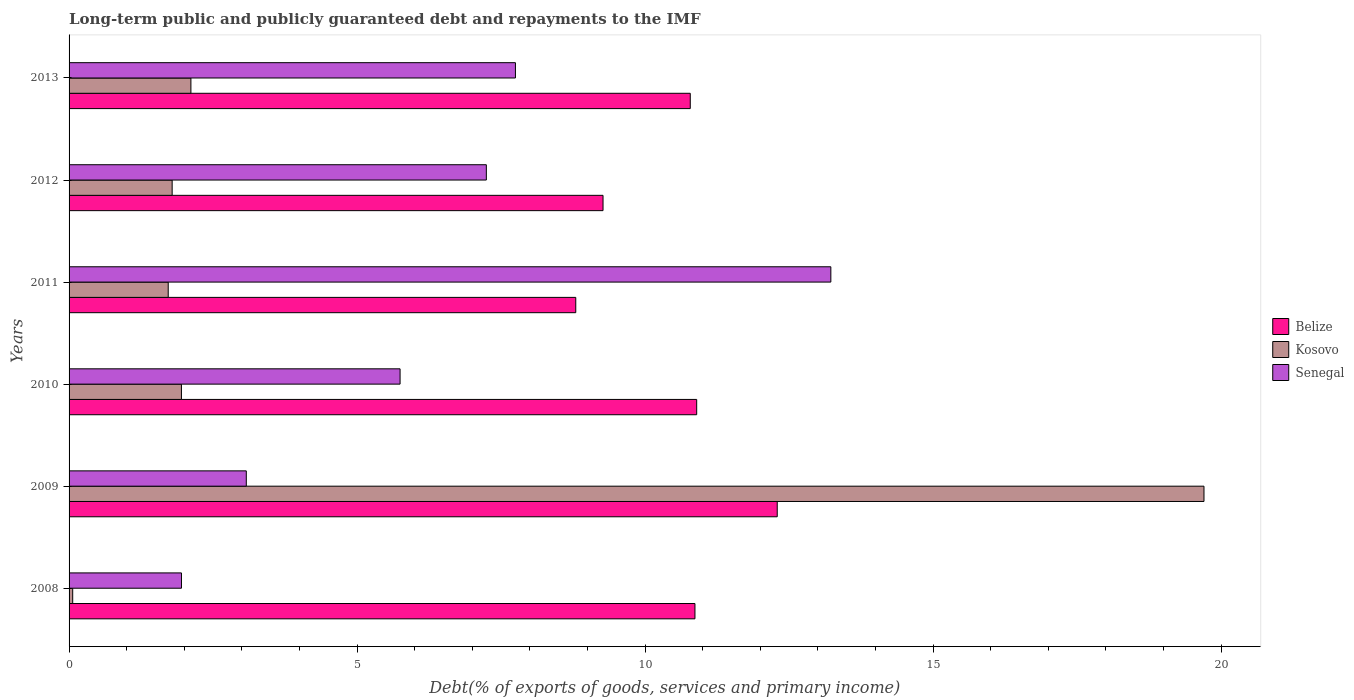How many different coloured bars are there?
Offer a terse response. 3. Are the number of bars per tick equal to the number of legend labels?
Give a very brief answer. Yes. How many bars are there on the 4th tick from the bottom?
Provide a short and direct response. 3. What is the debt and repayments in Kosovo in 2013?
Keep it short and to the point. 2.12. Across all years, what is the maximum debt and repayments in Kosovo?
Keep it short and to the point. 19.7. Across all years, what is the minimum debt and repayments in Belize?
Keep it short and to the point. 8.8. In which year was the debt and repayments in Belize maximum?
Ensure brevity in your answer.  2009. In which year was the debt and repayments in Belize minimum?
Your response must be concise. 2011. What is the total debt and repayments in Belize in the graph?
Offer a terse response. 62.91. What is the difference between the debt and repayments in Senegal in 2009 and that in 2011?
Provide a short and direct response. -10.15. What is the difference between the debt and repayments in Kosovo in 2010 and the debt and repayments in Senegal in 2009?
Your response must be concise. -1.13. What is the average debt and repayments in Belize per year?
Provide a short and direct response. 10.48. In the year 2009, what is the difference between the debt and repayments in Belize and debt and repayments in Kosovo?
Offer a terse response. -7.41. What is the ratio of the debt and repayments in Belize in 2008 to that in 2012?
Give a very brief answer. 1.17. Is the debt and repayments in Kosovo in 2011 less than that in 2013?
Provide a short and direct response. Yes. Is the difference between the debt and repayments in Belize in 2008 and 2012 greater than the difference between the debt and repayments in Kosovo in 2008 and 2012?
Offer a terse response. Yes. What is the difference between the highest and the second highest debt and repayments in Senegal?
Give a very brief answer. 5.48. What is the difference between the highest and the lowest debt and repayments in Belize?
Give a very brief answer. 3.5. What does the 2nd bar from the top in 2008 represents?
Your answer should be compact. Kosovo. What does the 3rd bar from the bottom in 2009 represents?
Provide a short and direct response. Senegal. Is it the case that in every year, the sum of the debt and repayments in Senegal and debt and repayments in Belize is greater than the debt and repayments in Kosovo?
Your answer should be compact. No. How many bars are there?
Make the answer very short. 18. Are all the bars in the graph horizontal?
Your answer should be very brief. Yes. How many years are there in the graph?
Offer a terse response. 6. Does the graph contain any zero values?
Ensure brevity in your answer.  No. Does the graph contain grids?
Keep it short and to the point. No. Where does the legend appear in the graph?
Your response must be concise. Center right. How many legend labels are there?
Your answer should be very brief. 3. How are the legend labels stacked?
Provide a short and direct response. Vertical. What is the title of the graph?
Give a very brief answer. Long-term public and publicly guaranteed debt and repayments to the IMF. Does "Madagascar" appear as one of the legend labels in the graph?
Give a very brief answer. No. What is the label or title of the X-axis?
Offer a very short reply. Debt(% of exports of goods, services and primary income). What is the label or title of the Y-axis?
Your answer should be compact. Years. What is the Debt(% of exports of goods, services and primary income) in Belize in 2008?
Offer a terse response. 10.87. What is the Debt(% of exports of goods, services and primary income) in Kosovo in 2008?
Offer a very short reply. 0.06. What is the Debt(% of exports of goods, services and primary income) in Senegal in 2008?
Your response must be concise. 1.95. What is the Debt(% of exports of goods, services and primary income) of Belize in 2009?
Offer a terse response. 12.29. What is the Debt(% of exports of goods, services and primary income) in Kosovo in 2009?
Offer a very short reply. 19.7. What is the Debt(% of exports of goods, services and primary income) of Senegal in 2009?
Provide a succinct answer. 3.08. What is the Debt(% of exports of goods, services and primary income) in Belize in 2010?
Keep it short and to the point. 10.9. What is the Debt(% of exports of goods, services and primary income) in Kosovo in 2010?
Provide a succinct answer. 1.95. What is the Debt(% of exports of goods, services and primary income) of Senegal in 2010?
Ensure brevity in your answer.  5.75. What is the Debt(% of exports of goods, services and primary income) in Belize in 2011?
Keep it short and to the point. 8.8. What is the Debt(% of exports of goods, services and primary income) in Kosovo in 2011?
Your answer should be very brief. 1.72. What is the Debt(% of exports of goods, services and primary income) of Senegal in 2011?
Ensure brevity in your answer.  13.22. What is the Debt(% of exports of goods, services and primary income) in Belize in 2012?
Offer a very short reply. 9.27. What is the Debt(% of exports of goods, services and primary income) in Kosovo in 2012?
Provide a short and direct response. 1.79. What is the Debt(% of exports of goods, services and primary income) in Senegal in 2012?
Ensure brevity in your answer.  7.24. What is the Debt(% of exports of goods, services and primary income) of Belize in 2013?
Offer a very short reply. 10.78. What is the Debt(% of exports of goods, services and primary income) of Kosovo in 2013?
Keep it short and to the point. 2.12. What is the Debt(% of exports of goods, services and primary income) of Senegal in 2013?
Offer a very short reply. 7.75. Across all years, what is the maximum Debt(% of exports of goods, services and primary income) of Belize?
Provide a short and direct response. 12.29. Across all years, what is the maximum Debt(% of exports of goods, services and primary income) in Kosovo?
Offer a very short reply. 19.7. Across all years, what is the maximum Debt(% of exports of goods, services and primary income) of Senegal?
Offer a terse response. 13.22. Across all years, what is the minimum Debt(% of exports of goods, services and primary income) in Belize?
Ensure brevity in your answer.  8.8. Across all years, what is the minimum Debt(% of exports of goods, services and primary income) of Kosovo?
Offer a very short reply. 0.06. Across all years, what is the minimum Debt(% of exports of goods, services and primary income) of Senegal?
Your answer should be very brief. 1.95. What is the total Debt(% of exports of goods, services and primary income) in Belize in the graph?
Offer a terse response. 62.91. What is the total Debt(% of exports of goods, services and primary income) in Kosovo in the graph?
Offer a very short reply. 27.34. What is the total Debt(% of exports of goods, services and primary income) of Senegal in the graph?
Keep it short and to the point. 38.99. What is the difference between the Debt(% of exports of goods, services and primary income) in Belize in 2008 and that in 2009?
Ensure brevity in your answer.  -1.43. What is the difference between the Debt(% of exports of goods, services and primary income) in Kosovo in 2008 and that in 2009?
Your response must be concise. -19.64. What is the difference between the Debt(% of exports of goods, services and primary income) in Senegal in 2008 and that in 2009?
Give a very brief answer. -1.13. What is the difference between the Debt(% of exports of goods, services and primary income) of Belize in 2008 and that in 2010?
Make the answer very short. -0.03. What is the difference between the Debt(% of exports of goods, services and primary income) in Kosovo in 2008 and that in 2010?
Offer a terse response. -1.89. What is the difference between the Debt(% of exports of goods, services and primary income) of Senegal in 2008 and that in 2010?
Offer a very short reply. -3.8. What is the difference between the Debt(% of exports of goods, services and primary income) of Belize in 2008 and that in 2011?
Your answer should be compact. 2.07. What is the difference between the Debt(% of exports of goods, services and primary income) in Kosovo in 2008 and that in 2011?
Offer a very short reply. -1.66. What is the difference between the Debt(% of exports of goods, services and primary income) in Senegal in 2008 and that in 2011?
Ensure brevity in your answer.  -11.27. What is the difference between the Debt(% of exports of goods, services and primary income) in Belize in 2008 and that in 2012?
Provide a short and direct response. 1.6. What is the difference between the Debt(% of exports of goods, services and primary income) of Kosovo in 2008 and that in 2012?
Your response must be concise. -1.73. What is the difference between the Debt(% of exports of goods, services and primary income) in Senegal in 2008 and that in 2012?
Ensure brevity in your answer.  -5.29. What is the difference between the Debt(% of exports of goods, services and primary income) of Belize in 2008 and that in 2013?
Provide a short and direct response. 0.08. What is the difference between the Debt(% of exports of goods, services and primary income) of Kosovo in 2008 and that in 2013?
Provide a short and direct response. -2.05. What is the difference between the Debt(% of exports of goods, services and primary income) of Senegal in 2008 and that in 2013?
Your response must be concise. -5.8. What is the difference between the Debt(% of exports of goods, services and primary income) of Belize in 2009 and that in 2010?
Ensure brevity in your answer.  1.4. What is the difference between the Debt(% of exports of goods, services and primary income) of Kosovo in 2009 and that in 2010?
Offer a very short reply. 17.75. What is the difference between the Debt(% of exports of goods, services and primary income) of Senegal in 2009 and that in 2010?
Provide a succinct answer. -2.67. What is the difference between the Debt(% of exports of goods, services and primary income) of Belize in 2009 and that in 2011?
Your answer should be compact. 3.5. What is the difference between the Debt(% of exports of goods, services and primary income) of Kosovo in 2009 and that in 2011?
Provide a short and direct response. 17.98. What is the difference between the Debt(% of exports of goods, services and primary income) of Senegal in 2009 and that in 2011?
Give a very brief answer. -10.15. What is the difference between the Debt(% of exports of goods, services and primary income) of Belize in 2009 and that in 2012?
Offer a very short reply. 3.02. What is the difference between the Debt(% of exports of goods, services and primary income) of Kosovo in 2009 and that in 2012?
Ensure brevity in your answer.  17.91. What is the difference between the Debt(% of exports of goods, services and primary income) in Senegal in 2009 and that in 2012?
Provide a succinct answer. -4.17. What is the difference between the Debt(% of exports of goods, services and primary income) of Belize in 2009 and that in 2013?
Provide a short and direct response. 1.51. What is the difference between the Debt(% of exports of goods, services and primary income) in Kosovo in 2009 and that in 2013?
Ensure brevity in your answer.  17.59. What is the difference between the Debt(% of exports of goods, services and primary income) in Senegal in 2009 and that in 2013?
Ensure brevity in your answer.  -4.67. What is the difference between the Debt(% of exports of goods, services and primary income) in Belize in 2010 and that in 2011?
Offer a very short reply. 2.1. What is the difference between the Debt(% of exports of goods, services and primary income) of Kosovo in 2010 and that in 2011?
Your response must be concise. 0.23. What is the difference between the Debt(% of exports of goods, services and primary income) of Senegal in 2010 and that in 2011?
Make the answer very short. -7.48. What is the difference between the Debt(% of exports of goods, services and primary income) in Belize in 2010 and that in 2012?
Provide a short and direct response. 1.63. What is the difference between the Debt(% of exports of goods, services and primary income) of Kosovo in 2010 and that in 2012?
Ensure brevity in your answer.  0.16. What is the difference between the Debt(% of exports of goods, services and primary income) of Senegal in 2010 and that in 2012?
Your answer should be very brief. -1.5. What is the difference between the Debt(% of exports of goods, services and primary income) in Belize in 2010 and that in 2013?
Give a very brief answer. 0.11. What is the difference between the Debt(% of exports of goods, services and primary income) in Kosovo in 2010 and that in 2013?
Your response must be concise. -0.16. What is the difference between the Debt(% of exports of goods, services and primary income) of Senegal in 2010 and that in 2013?
Provide a short and direct response. -2. What is the difference between the Debt(% of exports of goods, services and primary income) of Belize in 2011 and that in 2012?
Offer a very short reply. -0.47. What is the difference between the Debt(% of exports of goods, services and primary income) in Kosovo in 2011 and that in 2012?
Your response must be concise. -0.07. What is the difference between the Debt(% of exports of goods, services and primary income) of Senegal in 2011 and that in 2012?
Your answer should be very brief. 5.98. What is the difference between the Debt(% of exports of goods, services and primary income) of Belize in 2011 and that in 2013?
Ensure brevity in your answer.  -1.99. What is the difference between the Debt(% of exports of goods, services and primary income) of Kosovo in 2011 and that in 2013?
Your response must be concise. -0.39. What is the difference between the Debt(% of exports of goods, services and primary income) of Senegal in 2011 and that in 2013?
Your answer should be very brief. 5.48. What is the difference between the Debt(% of exports of goods, services and primary income) of Belize in 2012 and that in 2013?
Make the answer very short. -1.51. What is the difference between the Debt(% of exports of goods, services and primary income) of Kosovo in 2012 and that in 2013?
Offer a terse response. -0.33. What is the difference between the Debt(% of exports of goods, services and primary income) of Senegal in 2012 and that in 2013?
Give a very brief answer. -0.51. What is the difference between the Debt(% of exports of goods, services and primary income) in Belize in 2008 and the Debt(% of exports of goods, services and primary income) in Kosovo in 2009?
Keep it short and to the point. -8.84. What is the difference between the Debt(% of exports of goods, services and primary income) of Belize in 2008 and the Debt(% of exports of goods, services and primary income) of Senegal in 2009?
Your answer should be compact. 7.79. What is the difference between the Debt(% of exports of goods, services and primary income) of Kosovo in 2008 and the Debt(% of exports of goods, services and primary income) of Senegal in 2009?
Offer a very short reply. -3.01. What is the difference between the Debt(% of exports of goods, services and primary income) in Belize in 2008 and the Debt(% of exports of goods, services and primary income) in Kosovo in 2010?
Your answer should be compact. 8.91. What is the difference between the Debt(% of exports of goods, services and primary income) of Belize in 2008 and the Debt(% of exports of goods, services and primary income) of Senegal in 2010?
Your answer should be compact. 5.12. What is the difference between the Debt(% of exports of goods, services and primary income) in Kosovo in 2008 and the Debt(% of exports of goods, services and primary income) in Senegal in 2010?
Your answer should be compact. -5.68. What is the difference between the Debt(% of exports of goods, services and primary income) in Belize in 2008 and the Debt(% of exports of goods, services and primary income) in Kosovo in 2011?
Your answer should be very brief. 9.14. What is the difference between the Debt(% of exports of goods, services and primary income) of Belize in 2008 and the Debt(% of exports of goods, services and primary income) of Senegal in 2011?
Your answer should be compact. -2.36. What is the difference between the Debt(% of exports of goods, services and primary income) of Kosovo in 2008 and the Debt(% of exports of goods, services and primary income) of Senegal in 2011?
Provide a succinct answer. -13.16. What is the difference between the Debt(% of exports of goods, services and primary income) of Belize in 2008 and the Debt(% of exports of goods, services and primary income) of Kosovo in 2012?
Offer a terse response. 9.08. What is the difference between the Debt(% of exports of goods, services and primary income) in Belize in 2008 and the Debt(% of exports of goods, services and primary income) in Senegal in 2012?
Provide a succinct answer. 3.62. What is the difference between the Debt(% of exports of goods, services and primary income) in Kosovo in 2008 and the Debt(% of exports of goods, services and primary income) in Senegal in 2012?
Provide a short and direct response. -7.18. What is the difference between the Debt(% of exports of goods, services and primary income) of Belize in 2008 and the Debt(% of exports of goods, services and primary income) of Kosovo in 2013?
Your answer should be very brief. 8.75. What is the difference between the Debt(% of exports of goods, services and primary income) in Belize in 2008 and the Debt(% of exports of goods, services and primary income) in Senegal in 2013?
Provide a short and direct response. 3.12. What is the difference between the Debt(% of exports of goods, services and primary income) in Kosovo in 2008 and the Debt(% of exports of goods, services and primary income) in Senegal in 2013?
Provide a succinct answer. -7.69. What is the difference between the Debt(% of exports of goods, services and primary income) of Belize in 2009 and the Debt(% of exports of goods, services and primary income) of Kosovo in 2010?
Provide a short and direct response. 10.34. What is the difference between the Debt(% of exports of goods, services and primary income) in Belize in 2009 and the Debt(% of exports of goods, services and primary income) in Senegal in 2010?
Your answer should be very brief. 6.55. What is the difference between the Debt(% of exports of goods, services and primary income) in Kosovo in 2009 and the Debt(% of exports of goods, services and primary income) in Senegal in 2010?
Your answer should be very brief. 13.96. What is the difference between the Debt(% of exports of goods, services and primary income) of Belize in 2009 and the Debt(% of exports of goods, services and primary income) of Kosovo in 2011?
Provide a succinct answer. 10.57. What is the difference between the Debt(% of exports of goods, services and primary income) of Belize in 2009 and the Debt(% of exports of goods, services and primary income) of Senegal in 2011?
Offer a terse response. -0.93. What is the difference between the Debt(% of exports of goods, services and primary income) in Kosovo in 2009 and the Debt(% of exports of goods, services and primary income) in Senegal in 2011?
Your answer should be very brief. 6.48. What is the difference between the Debt(% of exports of goods, services and primary income) in Belize in 2009 and the Debt(% of exports of goods, services and primary income) in Kosovo in 2012?
Your answer should be very brief. 10.5. What is the difference between the Debt(% of exports of goods, services and primary income) of Belize in 2009 and the Debt(% of exports of goods, services and primary income) of Senegal in 2012?
Your answer should be compact. 5.05. What is the difference between the Debt(% of exports of goods, services and primary income) in Kosovo in 2009 and the Debt(% of exports of goods, services and primary income) in Senegal in 2012?
Your response must be concise. 12.46. What is the difference between the Debt(% of exports of goods, services and primary income) in Belize in 2009 and the Debt(% of exports of goods, services and primary income) in Kosovo in 2013?
Your response must be concise. 10.18. What is the difference between the Debt(% of exports of goods, services and primary income) in Belize in 2009 and the Debt(% of exports of goods, services and primary income) in Senegal in 2013?
Give a very brief answer. 4.54. What is the difference between the Debt(% of exports of goods, services and primary income) of Kosovo in 2009 and the Debt(% of exports of goods, services and primary income) of Senegal in 2013?
Offer a terse response. 11.95. What is the difference between the Debt(% of exports of goods, services and primary income) in Belize in 2010 and the Debt(% of exports of goods, services and primary income) in Kosovo in 2011?
Keep it short and to the point. 9.17. What is the difference between the Debt(% of exports of goods, services and primary income) in Belize in 2010 and the Debt(% of exports of goods, services and primary income) in Senegal in 2011?
Your response must be concise. -2.33. What is the difference between the Debt(% of exports of goods, services and primary income) of Kosovo in 2010 and the Debt(% of exports of goods, services and primary income) of Senegal in 2011?
Give a very brief answer. -11.27. What is the difference between the Debt(% of exports of goods, services and primary income) of Belize in 2010 and the Debt(% of exports of goods, services and primary income) of Kosovo in 2012?
Your response must be concise. 9.11. What is the difference between the Debt(% of exports of goods, services and primary income) of Belize in 2010 and the Debt(% of exports of goods, services and primary income) of Senegal in 2012?
Your answer should be compact. 3.65. What is the difference between the Debt(% of exports of goods, services and primary income) in Kosovo in 2010 and the Debt(% of exports of goods, services and primary income) in Senegal in 2012?
Provide a short and direct response. -5.29. What is the difference between the Debt(% of exports of goods, services and primary income) of Belize in 2010 and the Debt(% of exports of goods, services and primary income) of Kosovo in 2013?
Give a very brief answer. 8.78. What is the difference between the Debt(% of exports of goods, services and primary income) of Belize in 2010 and the Debt(% of exports of goods, services and primary income) of Senegal in 2013?
Provide a short and direct response. 3.15. What is the difference between the Debt(% of exports of goods, services and primary income) of Kosovo in 2010 and the Debt(% of exports of goods, services and primary income) of Senegal in 2013?
Your answer should be compact. -5.8. What is the difference between the Debt(% of exports of goods, services and primary income) in Belize in 2011 and the Debt(% of exports of goods, services and primary income) in Kosovo in 2012?
Ensure brevity in your answer.  7.01. What is the difference between the Debt(% of exports of goods, services and primary income) in Belize in 2011 and the Debt(% of exports of goods, services and primary income) in Senegal in 2012?
Your answer should be compact. 1.55. What is the difference between the Debt(% of exports of goods, services and primary income) of Kosovo in 2011 and the Debt(% of exports of goods, services and primary income) of Senegal in 2012?
Offer a terse response. -5.52. What is the difference between the Debt(% of exports of goods, services and primary income) of Belize in 2011 and the Debt(% of exports of goods, services and primary income) of Kosovo in 2013?
Offer a terse response. 6.68. What is the difference between the Debt(% of exports of goods, services and primary income) in Belize in 2011 and the Debt(% of exports of goods, services and primary income) in Senegal in 2013?
Make the answer very short. 1.05. What is the difference between the Debt(% of exports of goods, services and primary income) of Kosovo in 2011 and the Debt(% of exports of goods, services and primary income) of Senegal in 2013?
Provide a short and direct response. -6.03. What is the difference between the Debt(% of exports of goods, services and primary income) in Belize in 2012 and the Debt(% of exports of goods, services and primary income) in Kosovo in 2013?
Provide a short and direct response. 7.15. What is the difference between the Debt(% of exports of goods, services and primary income) of Belize in 2012 and the Debt(% of exports of goods, services and primary income) of Senegal in 2013?
Ensure brevity in your answer.  1.52. What is the difference between the Debt(% of exports of goods, services and primary income) of Kosovo in 2012 and the Debt(% of exports of goods, services and primary income) of Senegal in 2013?
Keep it short and to the point. -5.96. What is the average Debt(% of exports of goods, services and primary income) in Belize per year?
Your answer should be compact. 10.48. What is the average Debt(% of exports of goods, services and primary income) of Kosovo per year?
Make the answer very short. 4.56. What is the average Debt(% of exports of goods, services and primary income) in Senegal per year?
Your response must be concise. 6.5. In the year 2008, what is the difference between the Debt(% of exports of goods, services and primary income) of Belize and Debt(% of exports of goods, services and primary income) of Kosovo?
Ensure brevity in your answer.  10.8. In the year 2008, what is the difference between the Debt(% of exports of goods, services and primary income) of Belize and Debt(% of exports of goods, services and primary income) of Senegal?
Provide a succinct answer. 8.91. In the year 2008, what is the difference between the Debt(% of exports of goods, services and primary income) in Kosovo and Debt(% of exports of goods, services and primary income) in Senegal?
Offer a terse response. -1.89. In the year 2009, what is the difference between the Debt(% of exports of goods, services and primary income) of Belize and Debt(% of exports of goods, services and primary income) of Kosovo?
Ensure brevity in your answer.  -7.41. In the year 2009, what is the difference between the Debt(% of exports of goods, services and primary income) of Belize and Debt(% of exports of goods, services and primary income) of Senegal?
Your answer should be very brief. 9.22. In the year 2009, what is the difference between the Debt(% of exports of goods, services and primary income) of Kosovo and Debt(% of exports of goods, services and primary income) of Senegal?
Ensure brevity in your answer.  16.63. In the year 2010, what is the difference between the Debt(% of exports of goods, services and primary income) of Belize and Debt(% of exports of goods, services and primary income) of Kosovo?
Provide a short and direct response. 8.94. In the year 2010, what is the difference between the Debt(% of exports of goods, services and primary income) in Belize and Debt(% of exports of goods, services and primary income) in Senegal?
Your answer should be compact. 5.15. In the year 2010, what is the difference between the Debt(% of exports of goods, services and primary income) of Kosovo and Debt(% of exports of goods, services and primary income) of Senegal?
Ensure brevity in your answer.  -3.8. In the year 2011, what is the difference between the Debt(% of exports of goods, services and primary income) in Belize and Debt(% of exports of goods, services and primary income) in Kosovo?
Offer a terse response. 7.08. In the year 2011, what is the difference between the Debt(% of exports of goods, services and primary income) of Belize and Debt(% of exports of goods, services and primary income) of Senegal?
Your response must be concise. -4.43. In the year 2011, what is the difference between the Debt(% of exports of goods, services and primary income) of Kosovo and Debt(% of exports of goods, services and primary income) of Senegal?
Provide a succinct answer. -11.5. In the year 2012, what is the difference between the Debt(% of exports of goods, services and primary income) of Belize and Debt(% of exports of goods, services and primary income) of Kosovo?
Your response must be concise. 7.48. In the year 2012, what is the difference between the Debt(% of exports of goods, services and primary income) in Belize and Debt(% of exports of goods, services and primary income) in Senegal?
Keep it short and to the point. 2.03. In the year 2012, what is the difference between the Debt(% of exports of goods, services and primary income) in Kosovo and Debt(% of exports of goods, services and primary income) in Senegal?
Give a very brief answer. -5.45. In the year 2013, what is the difference between the Debt(% of exports of goods, services and primary income) in Belize and Debt(% of exports of goods, services and primary income) in Kosovo?
Your answer should be compact. 8.67. In the year 2013, what is the difference between the Debt(% of exports of goods, services and primary income) in Belize and Debt(% of exports of goods, services and primary income) in Senegal?
Provide a succinct answer. 3.04. In the year 2013, what is the difference between the Debt(% of exports of goods, services and primary income) of Kosovo and Debt(% of exports of goods, services and primary income) of Senegal?
Your response must be concise. -5.63. What is the ratio of the Debt(% of exports of goods, services and primary income) in Belize in 2008 to that in 2009?
Your answer should be very brief. 0.88. What is the ratio of the Debt(% of exports of goods, services and primary income) in Kosovo in 2008 to that in 2009?
Make the answer very short. 0. What is the ratio of the Debt(% of exports of goods, services and primary income) in Senegal in 2008 to that in 2009?
Your response must be concise. 0.63. What is the ratio of the Debt(% of exports of goods, services and primary income) of Belize in 2008 to that in 2010?
Make the answer very short. 1. What is the ratio of the Debt(% of exports of goods, services and primary income) in Kosovo in 2008 to that in 2010?
Ensure brevity in your answer.  0.03. What is the ratio of the Debt(% of exports of goods, services and primary income) of Senegal in 2008 to that in 2010?
Provide a short and direct response. 0.34. What is the ratio of the Debt(% of exports of goods, services and primary income) of Belize in 2008 to that in 2011?
Provide a succinct answer. 1.24. What is the ratio of the Debt(% of exports of goods, services and primary income) of Kosovo in 2008 to that in 2011?
Give a very brief answer. 0.04. What is the ratio of the Debt(% of exports of goods, services and primary income) of Senegal in 2008 to that in 2011?
Offer a very short reply. 0.15. What is the ratio of the Debt(% of exports of goods, services and primary income) of Belize in 2008 to that in 2012?
Provide a succinct answer. 1.17. What is the ratio of the Debt(% of exports of goods, services and primary income) in Kosovo in 2008 to that in 2012?
Give a very brief answer. 0.04. What is the ratio of the Debt(% of exports of goods, services and primary income) in Senegal in 2008 to that in 2012?
Keep it short and to the point. 0.27. What is the ratio of the Debt(% of exports of goods, services and primary income) in Belize in 2008 to that in 2013?
Offer a terse response. 1.01. What is the ratio of the Debt(% of exports of goods, services and primary income) of Kosovo in 2008 to that in 2013?
Give a very brief answer. 0.03. What is the ratio of the Debt(% of exports of goods, services and primary income) in Senegal in 2008 to that in 2013?
Keep it short and to the point. 0.25. What is the ratio of the Debt(% of exports of goods, services and primary income) in Belize in 2009 to that in 2010?
Provide a succinct answer. 1.13. What is the ratio of the Debt(% of exports of goods, services and primary income) in Kosovo in 2009 to that in 2010?
Keep it short and to the point. 10.1. What is the ratio of the Debt(% of exports of goods, services and primary income) in Senegal in 2009 to that in 2010?
Keep it short and to the point. 0.54. What is the ratio of the Debt(% of exports of goods, services and primary income) of Belize in 2009 to that in 2011?
Offer a very short reply. 1.4. What is the ratio of the Debt(% of exports of goods, services and primary income) in Kosovo in 2009 to that in 2011?
Provide a short and direct response. 11.45. What is the ratio of the Debt(% of exports of goods, services and primary income) in Senegal in 2009 to that in 2011?
Your response must be concise. 0.23. What is the ratio of the Debt(% of exports of goods, services and primary income) in Belize in 2009 to that in 2012?
Provide a short and direct response. 1.33. What is the ratio of the Debt(% of exports of goods, services and primary income) of Kosovo in 2009 to that in 2012?
Offer a very short reply. 11.01. What is the ratio of the Debt(% of exports of goods, services and primary income) of Senegal in 2009 to that in 2012?
Your answer should be very brief. 0.42. What is the ratio of the Debt(% of exports of goods, services and primary income) of Belize in 2009 to that in 2013?
Offer a very short reply. 1.14. What is the ratio of the Debt(% of exports of goods, services and primary income) of Kosovo in 2009 to that in 2013?
Ensure brevity in your answer.  9.32. What is the ratio of the Debt(% of exports of goods, services and primary income) of Senegal in 2009 to that in 2013?
Provide a succinct answer. 0.4. What is the ratio of the Debt(% of exports of goods, services and primary income) in Belize in 2010 to that in 2011?
Ensure brevity in your answer.  1.24. What is the ratio of the Debt(% of exports of goods, services and primary income) of Kosovo in 2010 to that in 2011?
Keep it short and to the point. 1.13. What is the ratio of the Debt(% of exports of goods, services and primary income) in Senegal in 2010 to that in 2011?
Make the answer very short. 0.43. What is the ratio of the Debt(% of exports of goods, services and primary income) in Belize in 2010 to that in 2012?
Keep it short and to the point. 1.18. What is the ratio of the Debt(% of exports of goods, services and primary income) of Kosovo in 2010 to that in 2012?
Provide a short and direct response. 1.09. What is the ratio of the Debt(% of exports of goods, services and primary income) in Senegal in 2010 to that in 2012?
Keep it short and to the point. 0.79. What is the ratio of the Debt(% of exports of goods, services and primary income) of Belize in 2010 to that in 2013?
Make the answer very short. 1.01. What is the ratio of the Debt(% of exports of goods, services and primary income) of Kosovo in 2010 to that in 2013?
Your response must be concise. 0.92. What is the ratio of the Debt(% of exports of goods, services and primary income) in Senegal in 2010 to that in 2013?
Provide a succinct answer. 0.74. What is the ratio of the Debt(% of exports of goods, services and primary income) in Belize in 2011 to that in 2012?
Your answer should be compact. 0.95. What is the ratio of the Debt(% of exports of goods, services and primary income) of Kosovo in 2011 to that in 2012?
Ensure brevity in your answer.  0.96. What is the ratio of the Debt(% of exports of goods, services and primary income) in Senegal in 2011 to that in 2012?
Offer a terse response. 1.83. What is the ratio of the Debt(% of exports of goods, services and primary income) in Belize in 2011 to that in 2013?
Your response must be concise. 0.82. What is the ratio of the Debt(% of exports of goods, services and primary income) in Kosovo in 2011 to that in 2013?
Provide a succinct answer. 0.81. What is the ratio of the Debt(% of exports of goods, services and primary income) of Senegal in 2011 to that in 2013?
Provide a succinct answer. 1.71. What is the ratio of the Debt(% of exports of goods, services and primary income) of Belize in 2012 to that in 2013?
Your answer should be compact. 0.86. What is the ratio of the Debt(% of exports of goods, services and primary income) in Kosovo in 2012 to that in 2013?
Your answer should be compact. 0.85. What is the ratio of the Debt(% of exports of goods, services and primary income) of Senegal in 2012 to that in 2013?
Offer a very short reply. 0.93. What is the difference between the highest and the second highest Debt(% of exports of goods, services and primary income) of Belize?
Give a very brief answer. 1.4. What is the difference between the highest and the second highest Debt(% of exports of goods, services and primary income) of Kosovo?
Your answer should be very brief. 17.59. What is the difference between the highest and the second highest Debt(% of exports of goods, services and primary income) in Senegal?
Offer a very short reply. 5.48. What is the difference between the highest and the lowest Debt(% of exports of goods, services and primary income) of Belize?
Keep it short and to the point. 3.5. What is the difference between the highest and the lowest Debt(% of exports of goods, services and primary income) in Kosovo?
Your answer should be compact. 19.64. What is the difference between the highest and the lowest Debt(% of exports of goods, services and primary income) of Senegal?
Ensure brevity in your answer.  11.27. 